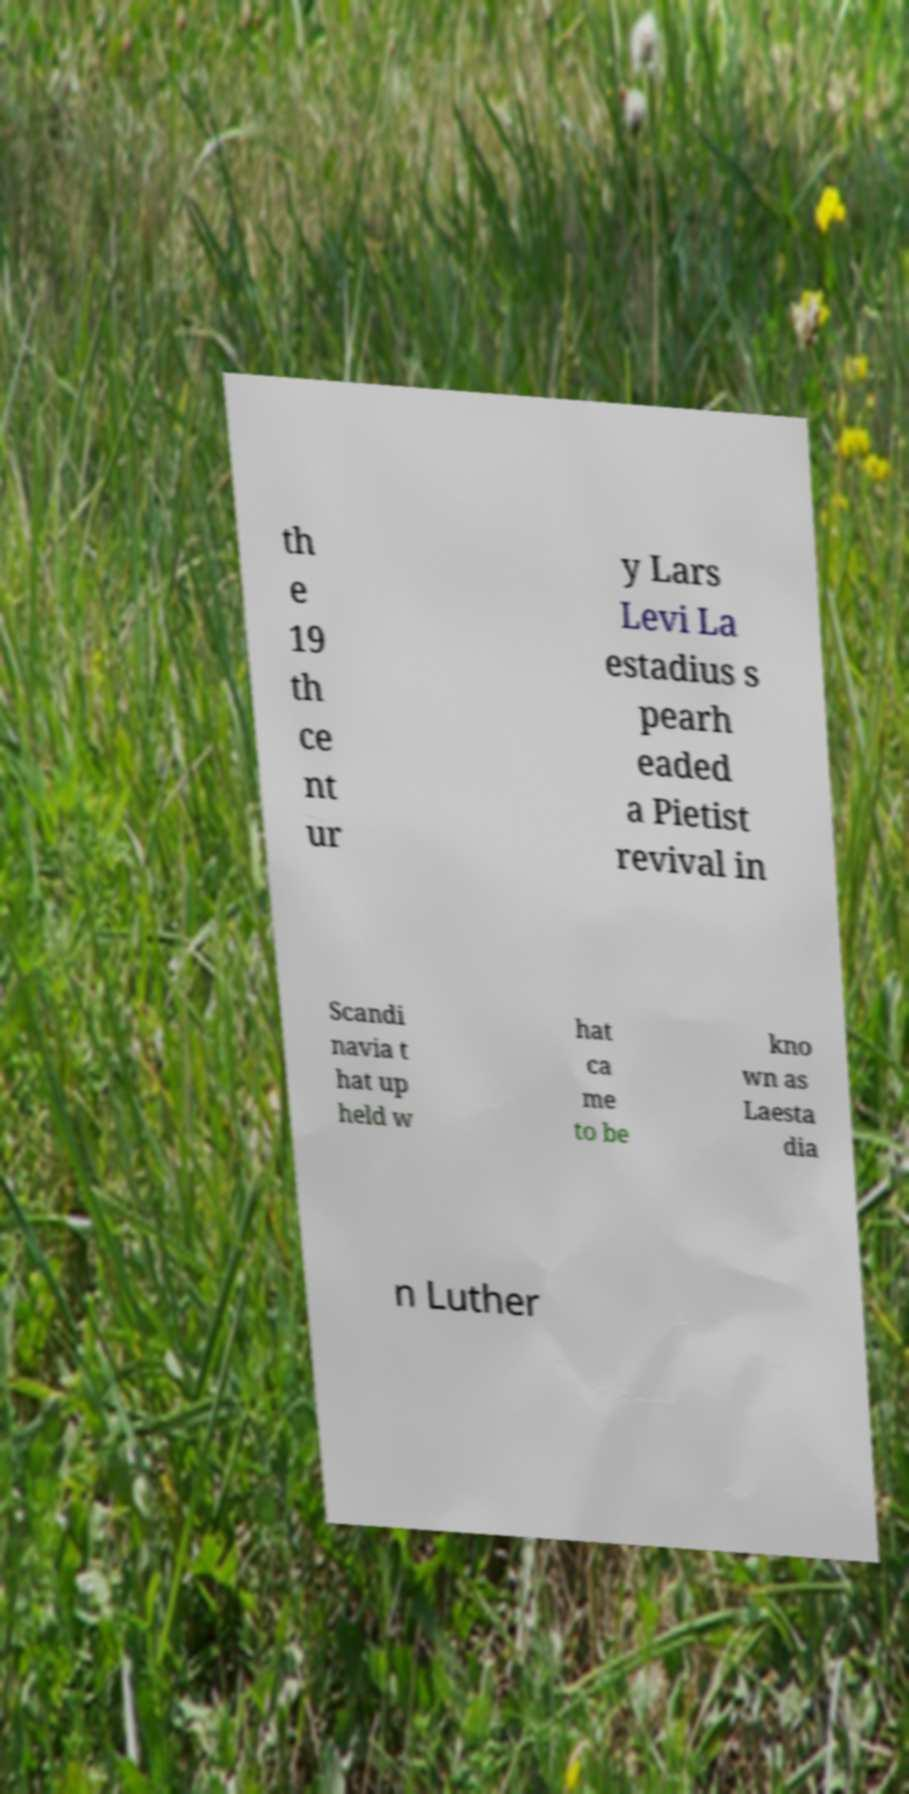Could you assist in decoding the text presented in this image and type it out clearly? th e 19 th ce nt ur y Lars Levi La estadius s pearh eaded a Pietist revival in Scandi navia t hat up held w hat ca me to be kno wn as Laesta dia n Luther 